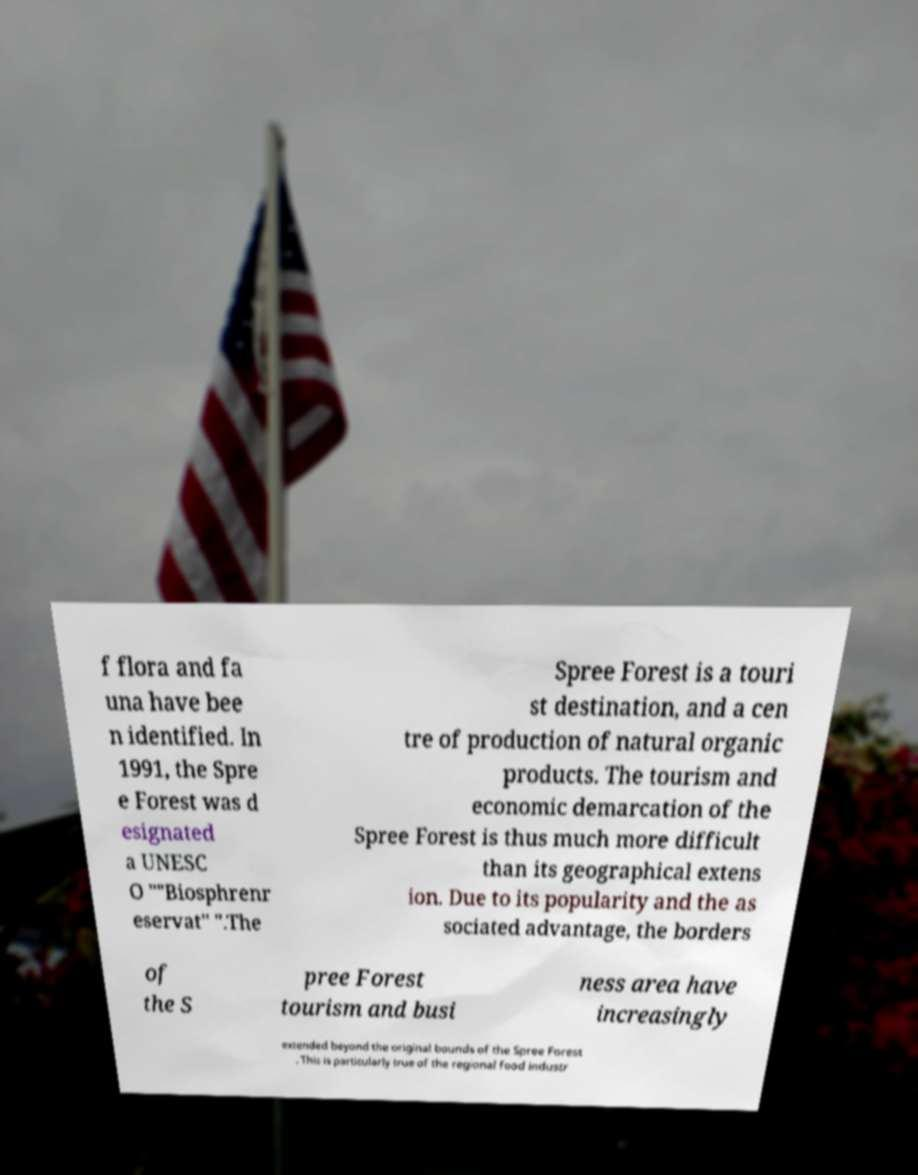Please identify and transcribe the text found in this image. f flora and fa una have bee n identified. In 1991, the Spre e Forest was d esignated a UNESC O ""Biosphrenr eservat" ".The Spree Forest is a touri st destination, and a cen tre of production of natural organic products. The tourism and economic demarcation of the Spree Forest is thus much more difficult than its geographical extens ion. Due to its popularity and the as sociated advantage, the borders of the S pree Forest tourism and busi ness area have increasingly extended beyond the original bounds of the Spree Forest . This is particularly true of the regional food industr 